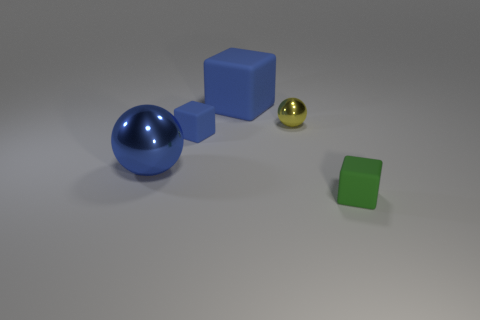Are there any tiny cyan things made of the same material as the tiny yellow object? In the image provided, there are no tiny cyan objects that appear to be made from the same material as the tiny yellow object. The yellow object seems to be a small, shiny sphere, which could be indicative of a metallic finish, and there are no cyan objects sharing that characteristic. 